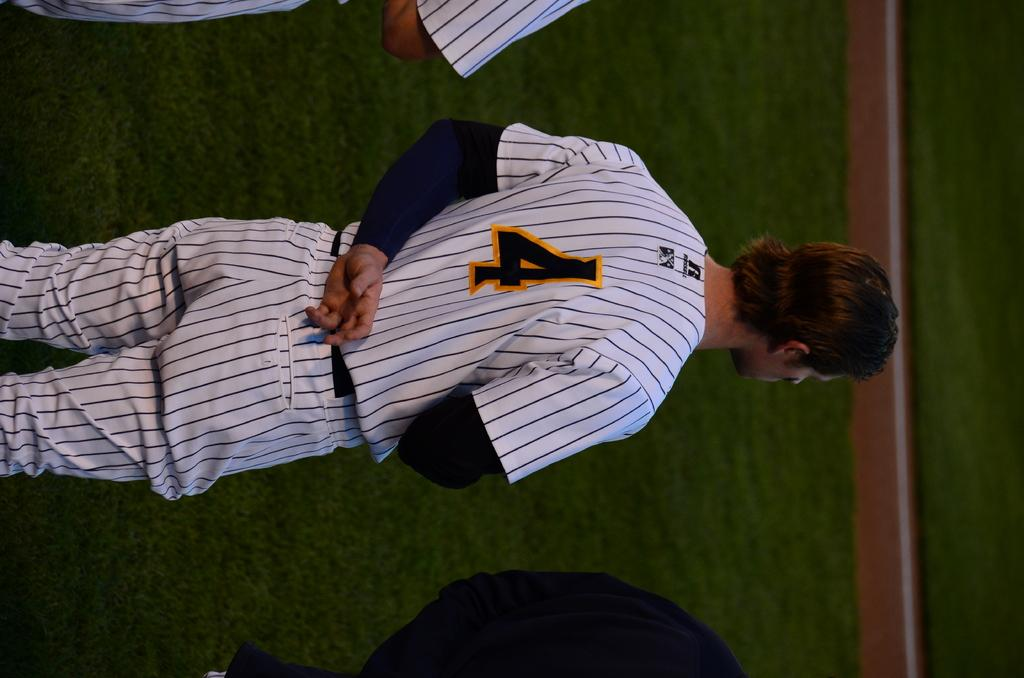<image>
Provide a brief description of the given image. Baseball player wearing number 4 standing in line. 